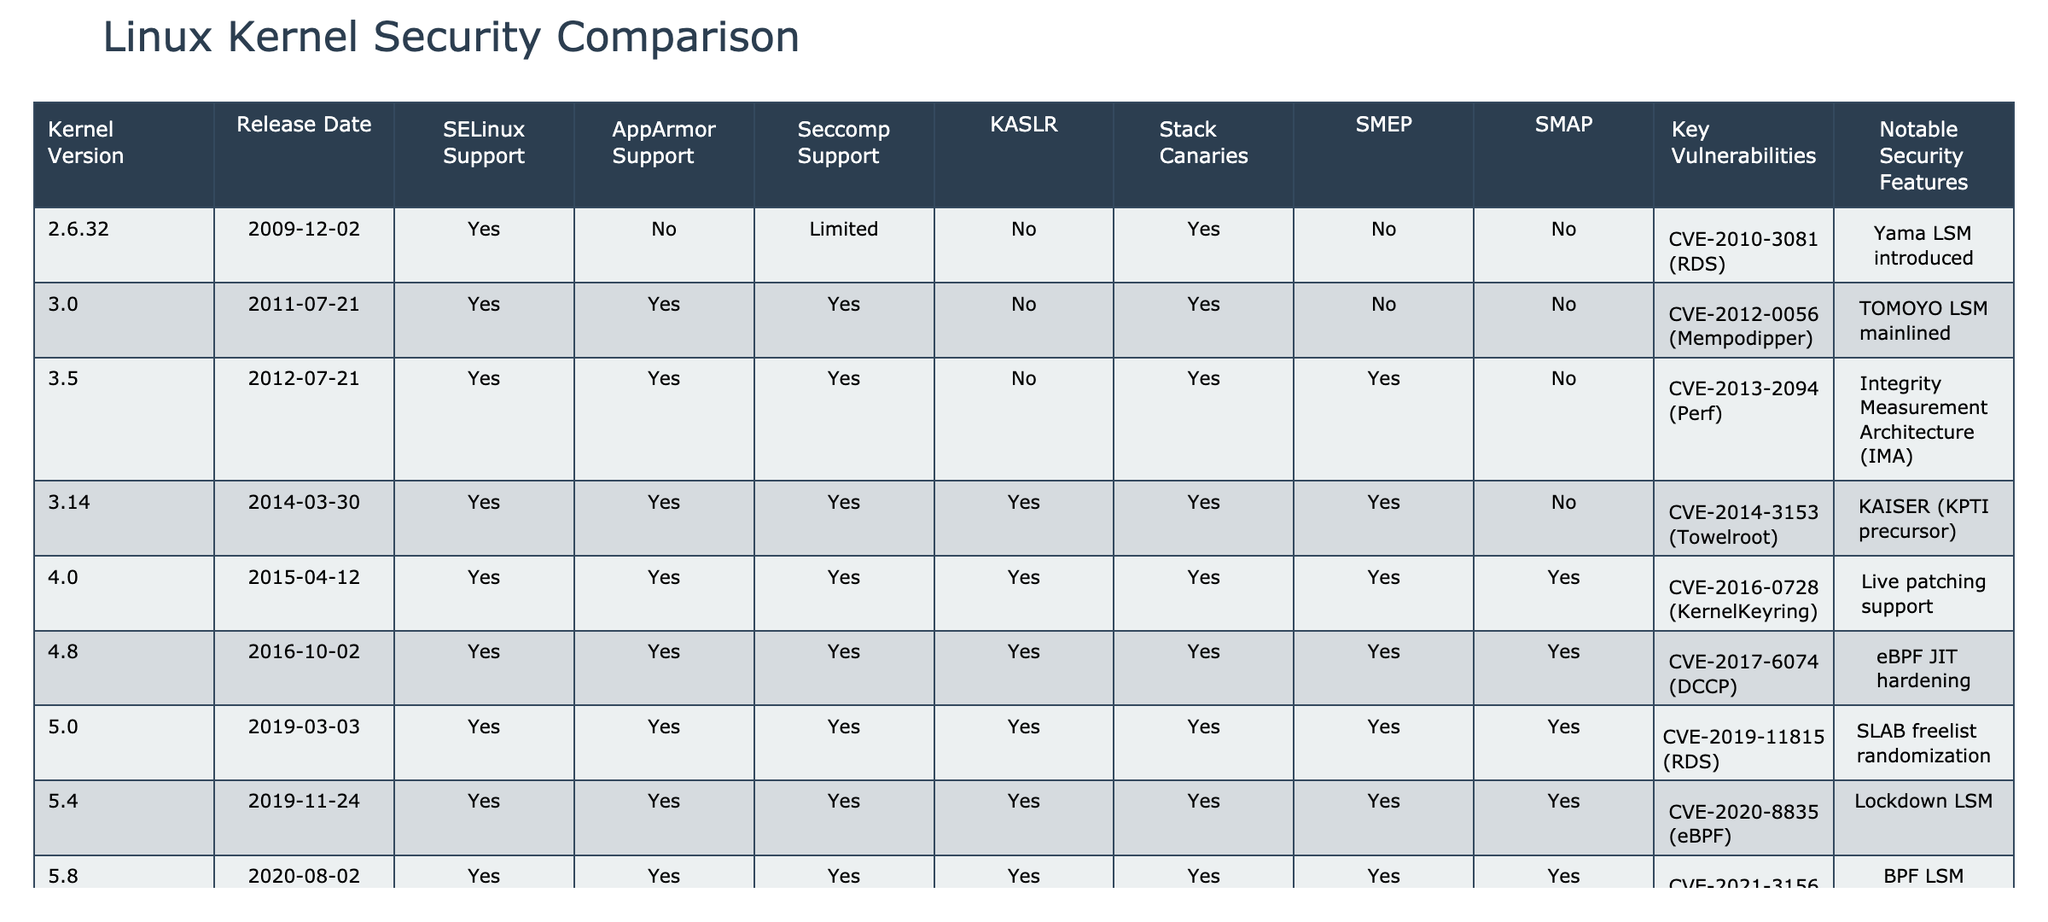What is the kernel version that first introduced SMEP support? The table shows that SMEP support was first included in version 3.5, which was released on 2012-07-21.
Answer: 3.5 How many kernel versions have AppArmor support? By counting the 'Yes' entries in the AppArmor Support column, there are 8 kernel versions that support AppArmor.
Answer: 8 Did the kernel version 5.4 include support for Seccomp? Looking at the row for version 5.4, the Seccomp Support column indicates 'Yes', confirming that this version did include Seccomp support.
Answer: Yes Which kernel version introduced the Lockdown LSM? The table indicates that the Lockdown LSM was introduced in kernel version 5.4, as it is listed in the Notable Security Features for that version.
Answer: 5.4 What are the notable security features introduced from kernel version 5.0 to 5.15? Notable features during this range include SLAB freelist randomization (5.0), Lockdown LSM (5.4), BPF LSM (5.8), and Core scheduling (5.15).
Answer: SLAB freelist randomization, Lockdown LSM, BPF LSM, Core scheduling How does the number of notable security features correlate with the inclusion of KASLR in kernel versions from 3.14 onwards? From kernel version 3.14 onward, KASLR is included in versions 3.14, 4.0, 4.8, 5.0, 5.4, 5.8, and 5.15. The notable security features for these versions are KAISER (4.0), eBPF JIT hardening (4.8), SLAB freelist randomization (5.0), Lockdown LSM (5.4), BPF LSM (5.8), and Core scheduling (5.15). As we can see, each of these versions has at least one notable security feature, suggesting a positive correlation.
Answer: There is a positive correlation How many kernel versions include both SELinux and AppArmor support? By reviewing the table, we see that all versions from 3.0 onward include both SELinux and AppArmor support, totaling six versions.
Answer: 6 Which kernel versions had significant vulnerabilities related to the KernelKeyring? The only significant vulnerability related to KernelKeyring appears in version 4.0 with CVE-2016-0728. Hence, 4.0 is the relevant version.
Answer: 4.0 Are there any kernel versions listed without support for Stack Canaries? Examining the table, the kernel versions 2.6.32 and 3.0 have 'No' in the Stack Canaries column, indicating these versions do not have this support.
Answer: Yes 